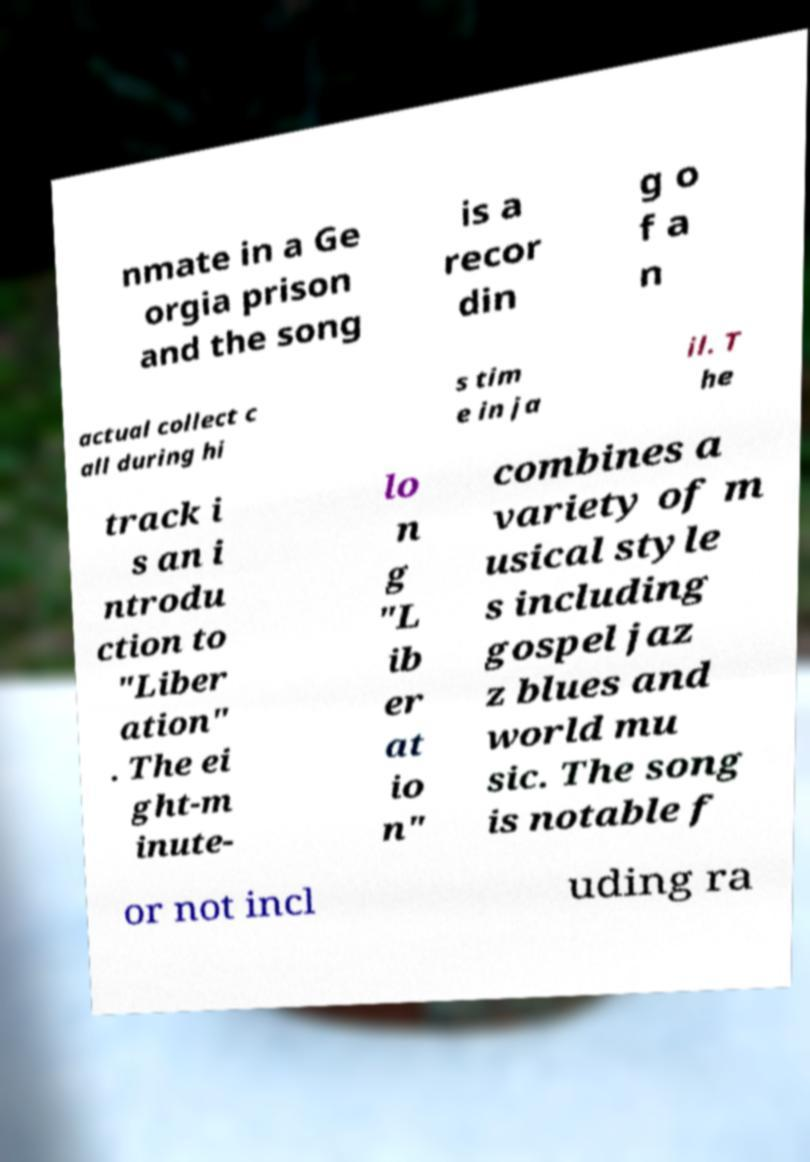For documentation purposes, I need the text within this image transcribed. Could you provide that? nmate in a Ge orgia prison and the song is a recor din g o f a n actual collect c all during hi s tim e in ja il. T he track i s an i ntrodu ction to "Liber ation" . The ei ght-m inute- lo n g "L ib er at io n" combines a variety of m usical style s including gospel jaz z blues and world mu sic. The song is notable f or not incl uding ra 